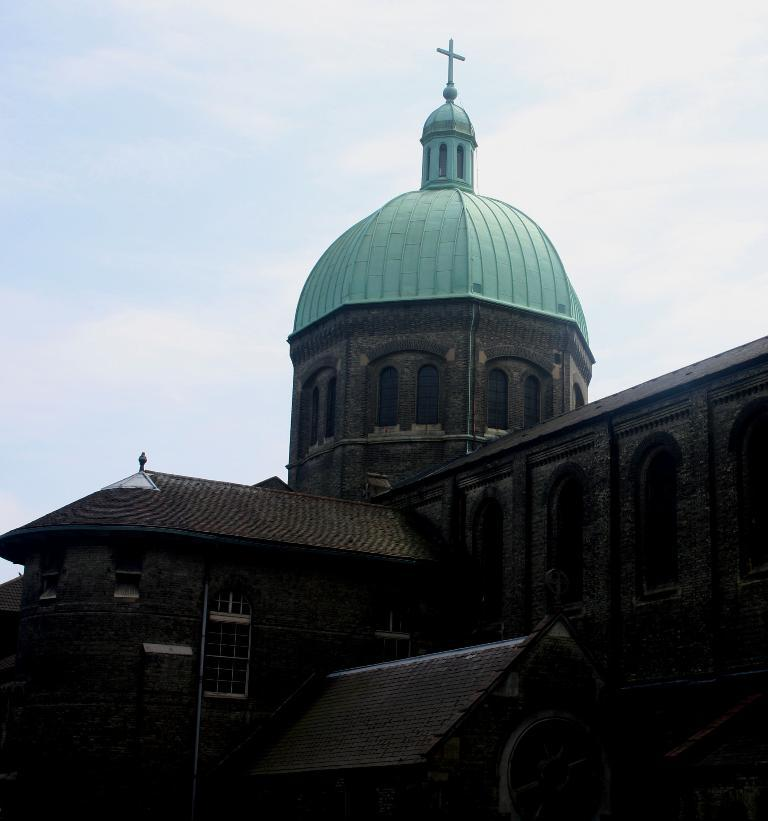What type of structure is in the image? There is a building in the image. What is the color of the building? The building is brown in color. What feature can be seen on top of the building? There is a green dome on the building. What religious symbol is present on the building? There is a cross on the building. What can be seen in the background of the image? The sky is visible in the background of the image. What type of berry is being served for breakfast in the image? There is no berry or breakfast scene present in the image; it features a building with a green dome and a cross. 